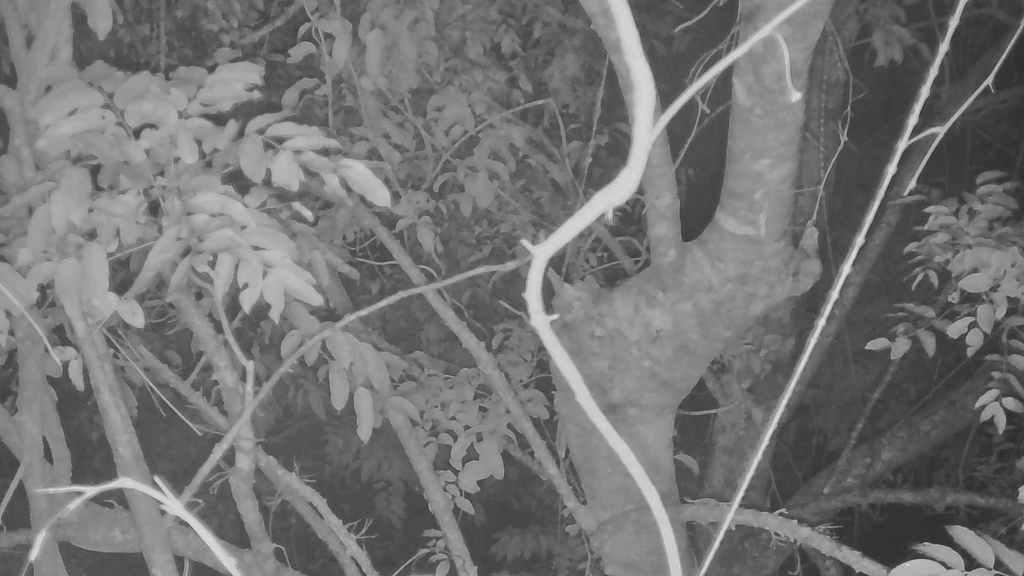What is the color scheme of the image? The image is black and white. What type of natural elements can be seen in the image? There are trees and leaves in the image. Can you describe the main subject of the image? There is a tree trunk in the middle of the image. What else is present near the tree trunk? There are wooden sticks beside the tree trunk. How many laborers are visible in the image? There are no laborers present in the image. What type of twist can be seen in the image? There is no twist visible in the image. 